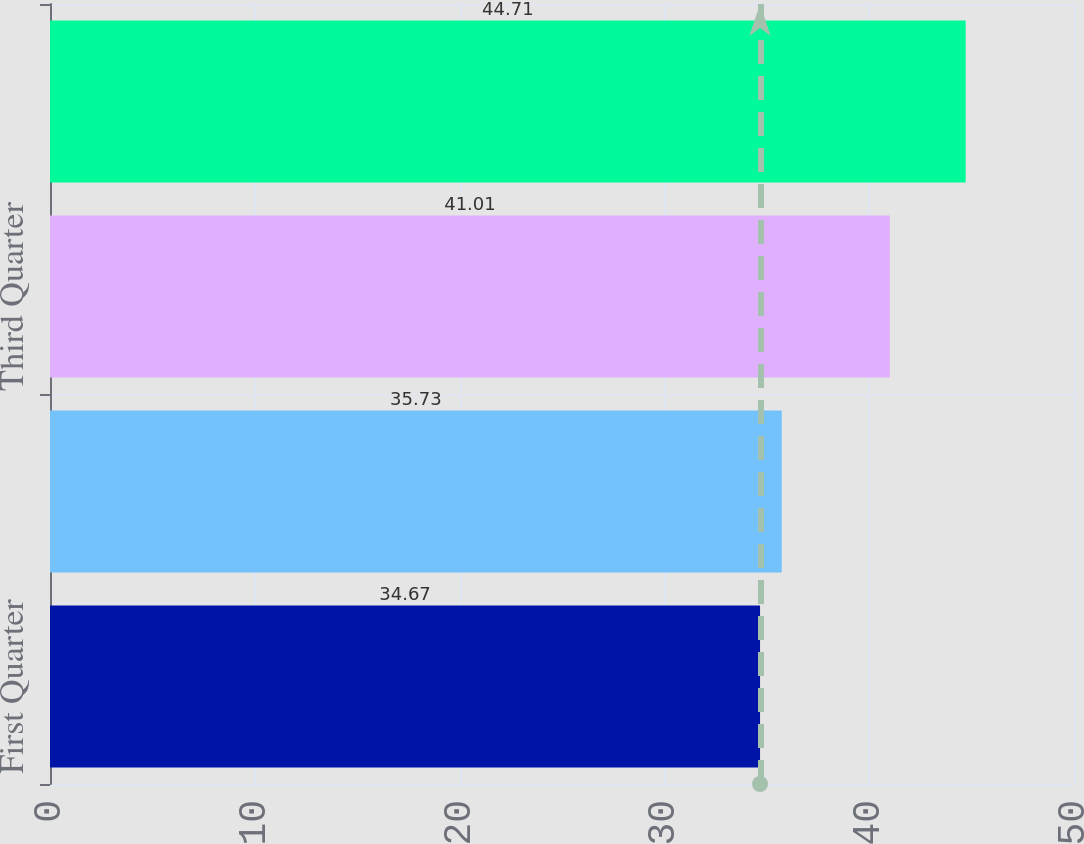Convert chart to OTSL. <chart><loc_0><loc_0><loc_500><loc_500><bar_chart><fcel>First Quarter<fcel>Second Quarter<fcel>Third Quarter<fcel>Fourth Quarter<nl><fcel>34.67<fcel>35.73<fcel>41.01<fcel>44.71<nl></chart> 